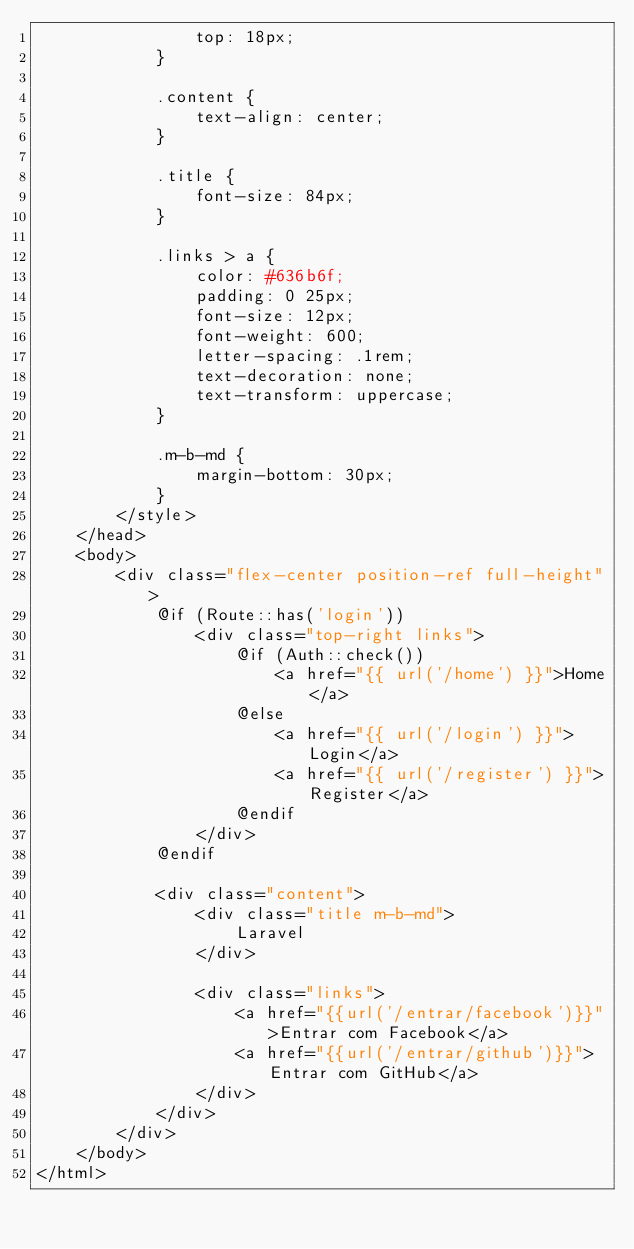<code> <loc_0><loc_0><loc_500><loc_500><_PHP_>                top: 18px;
            }

            .content {
                text-align: center;
            }

            .title {
                font-size: 84px;
            }

            .links > a {
                color: #636b6f;
                padding: 0 25px;
                font-size: 12px;
                font-weight: 600;
                letter-spacing: .1rem;
                text-decoration: none;
                text-transform: uppercase;
            }

            .m-b-md {
                margin-bottom: 30px;
            }
        </style>
    </head>
    <body>
        <div class="flex-center position-ref full-height">
            @if (Route::has('login'))
                <div class="top-right links">
                    @if (Auth::check())
                        <a href="{{ url('/home') }}">Home</a>
                    @else
                        <a href="{{ url('/login') }}">Login</a>
                        <a href="{{ url('/register') }}">Register</a>
                    @endif
                </div>
            @endif

            <div class="content">
                <div class="title m-b-md">
                    Laravel
                </div>

                <div class="links">
                    <a href="{{url('/entrar/facebook')}}">Entrar com Facebook</a>
                    <a href="{{url('/entrar/github')}}">Entrar com GitHub</a>
                </div>
            </div>
        </div>
    </body>
</html>
</code> 